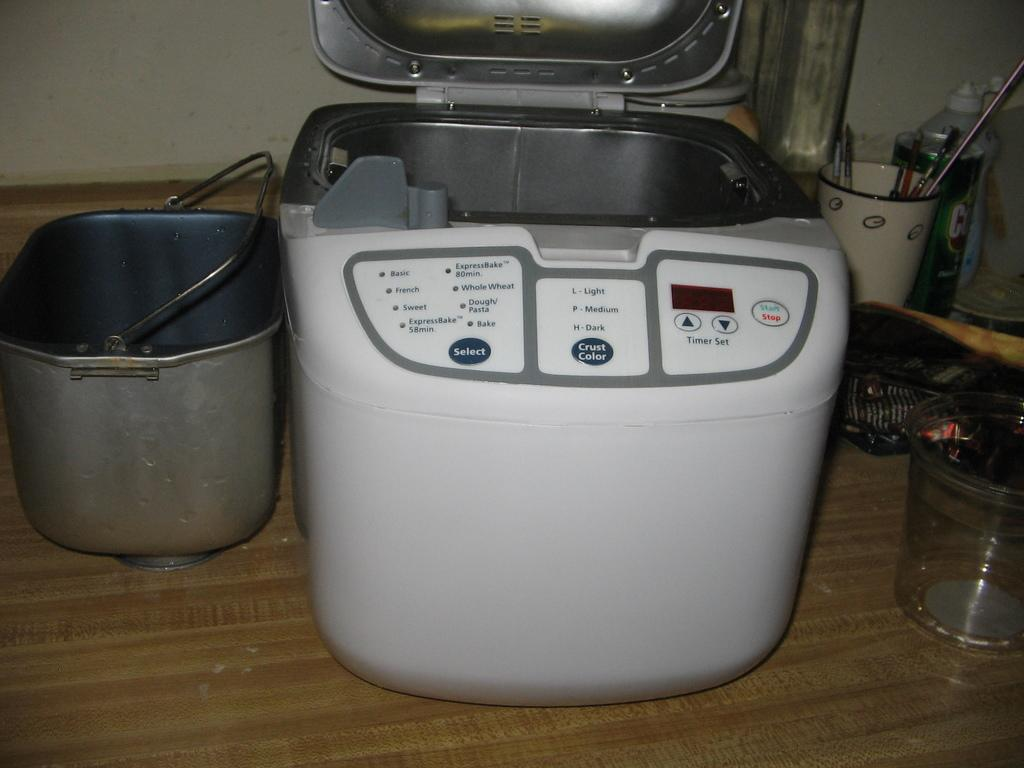<image>
Present a compact description of the photo's key features. A bread machine sits on a counter that allows one to pick the Crust Color. 